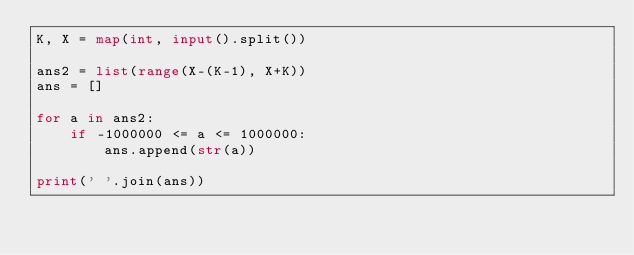Convert code to text. <code><loc_0><loc_0><loc_500><loc_500><_Python_>K, X = map(int, input().split())

ans2 = list(range(X-(K-1), X+K))
ans = []

for a in ans2:
    if -1000000 <= a <= 1000000:
        ans.append(str(a))

print(' '.join(ans))
</code> 